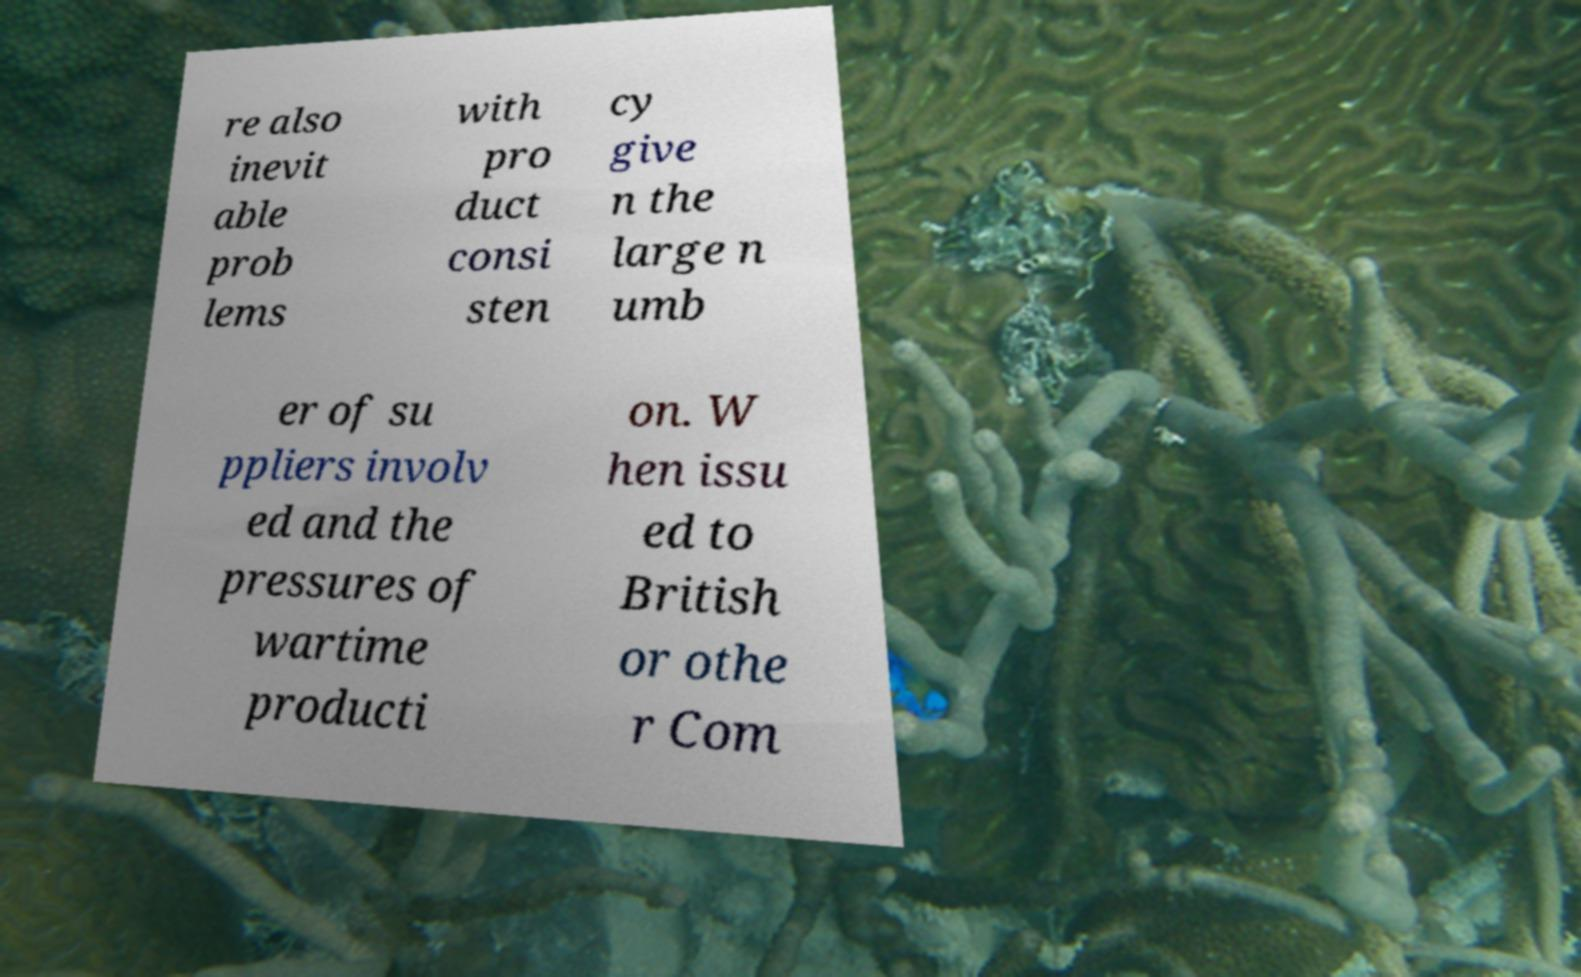Could you assist in decoding the text presented in this image and type it out clearly? re also inevit able prob lems with pro duct consi sten cy give n the large n umb er of su ppliers involv ed and the pressures of wartime producti on. W hen issu ed to British or othe r Com 